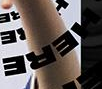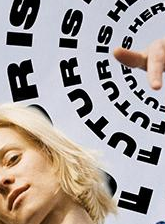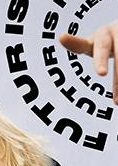Read the text content from these images in order, separated by a semicolon. HERE; FUTURIS; FUTURIS 